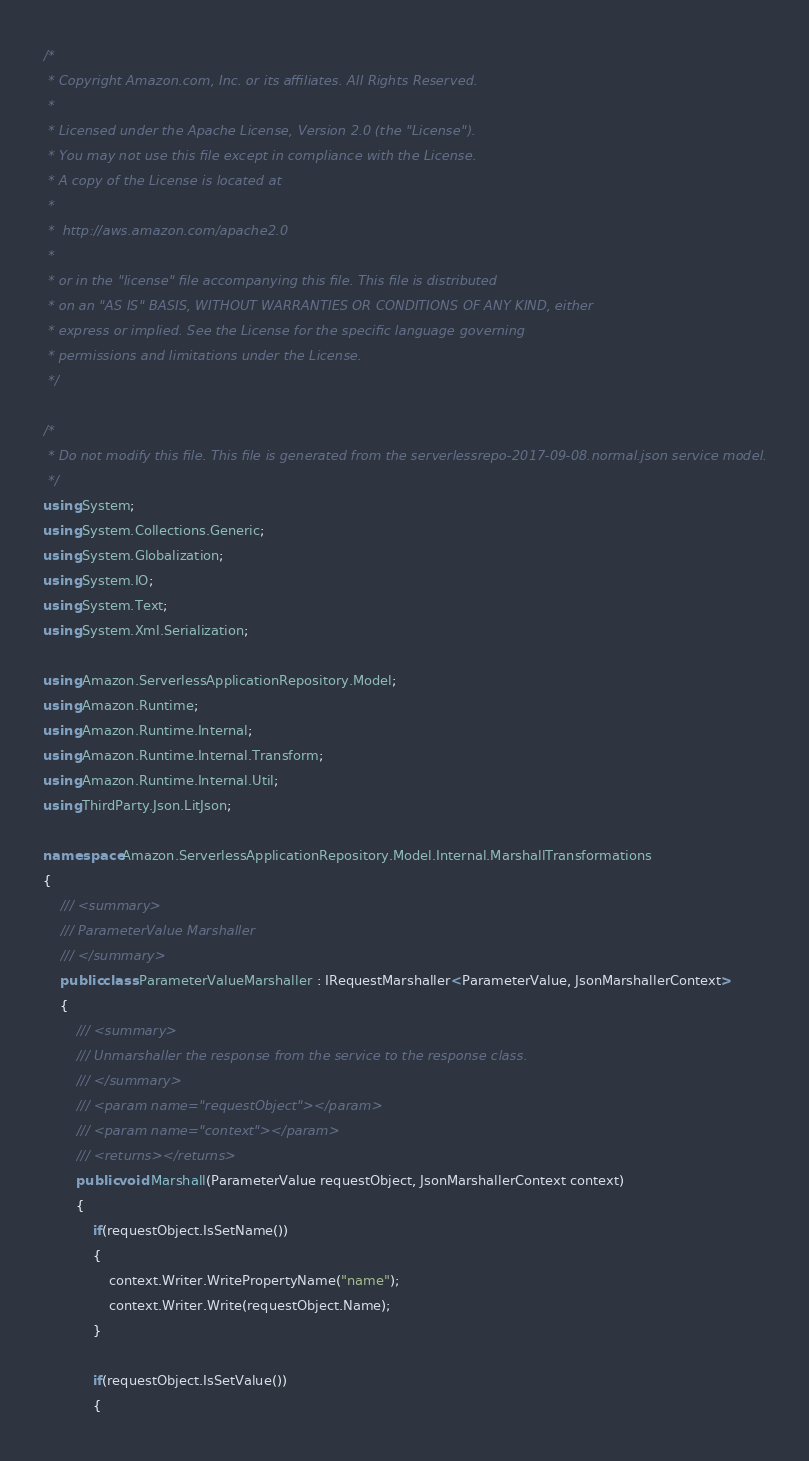<code> <loc_0><loc_0><loc_500><loc_500><_C#_>/*
 * Copyright Amazon.com, Inc. or its affiliates. All Rights Reserved.
 * 
 * Licensed under the Apache License, Version 2.0 (the "License").
 * You may not use this file except in compliance with the License.
 * A copy of the License is located at
 * 
 *  http://aws.amazon.com/apache2.0
 * 
 * or in the "license" file accompanying this file. This file is distributed
 * on an "AS IS" BASIS, WITHOUT WARRANTIES OR CONDITIONS OF ANY KIND, either
 * express or implied. See the License for the specific language governing
 * permissions and limitations under the License.
 */

/*
 * Do not modify this file. This file is generated from the serverlessrepo-2017-09-08.normal.json service model.
 */
using System;
using System.Collections.Generic;
using System.Globalization;
using System.IO;
using System.Text;
using System.Xml.Serialization;

using Amazon.ServerlessApplicationRepository.Model;
using Amazon.Runtime;
using Amazon.Runtime.Internal;
using Amazon.Runtime.Internal.Transform;
using Amazon.Runtime.Internal.Util;
using ThirdParty.Json.LitJson;

namespace Amazon.ServerlessApplicationRepository.Model.Internal.MarshallTransformations
{
    /// <summary>
    /// ParameterValue Marshaller
    /// </summary>       
    public class ParameterValueMarshaller : IRequestMarshaller<ParameterValue, JsonMarshallerContext> 
    {
        /// <summary>
        /// Unmarshaller the response from the service to the response class.
        /// </summary>  
        /// <param name="requestObject"></param>
        /// <param name="context"></param>
        /// <returns></returns>
        public void Marshall(ParameterValue requestObject, JsonMarshallerContext context)
        {
            if(requestObject.IsSetName())
            {
                context.Writer.WritePropertyName("name");
                context.Writer.Write(requestObject.Name);
            }

            if(requestObject.IsSetValue())
            {</code> 